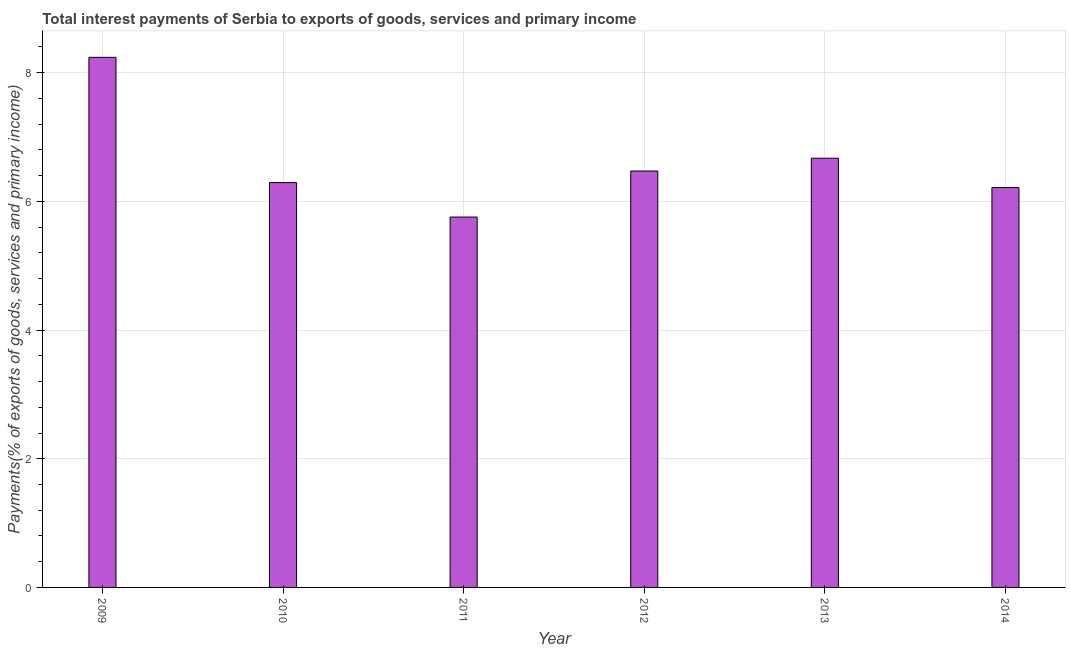Does the graph contain any zero values?
Keep it short and to the point. No. Does the graph contain grids?
Offer a terse response. Yes. What is the title of the graph?
Make the answer very short. Total interest payments of Serbia to exports of goods, services and primary income. What is the label or title of the X-axis?
Provide a succinct answer. Year. What is the label or title of the Y-axis?
Keep it short and to the point. Payments(% of exports of goods, services and primary income). What is the total interest payments on external debt in 2014?
Your answer should be compact. 6.21. Across all years, what is the maximum total interest payments on external debt?
Offer a very short reply. 8.24. Across all years, what is the minimum total interest payments on external debt?
Your answer should be very brief. 5.76. In which year was the total interest payments on external debt minimum?
Your response must be concise. 2011. What is the sum of the total interest payments on external debt?
Provide a short and direct response. 39.64. What is the difference between the total interest payments on external debt in 2011 and 2014?
Offer a very short reply. -0.46. What is the average total interest payments on external debt per year?
Offer a very short reply. 6.61. What is the median total interest payments on external debt?
Your answer should be compact. 6.38. In how many years, is the total interest payments on external debt greater than 2 %?
Ensure brevity in your answer.  6. What is the ratio of the total interest payments on external debt in 2009 to that in 2013?
Your response must be concise. 1.24. Is the total interest payments on external debt in 2009 less than that in 2012?
Offer a terse response. No. What is the difference between the highest and the second highest total interest payments on external debt?
Give a very brief answer. 1.57. What is the difference between the highest and the lowest total interest payments on external debt?
Offer a terse response. 2.48. In how many years, is the total interest payments on external debt greater than the average total interest payments on external debt taken over all years?
Give a very brief answer. 2. Are all the bars in the graph horizontal?
Provide a succinct answer. No. How many years are there in the graph?
Your answer should be compact. 6. What is the difference between two consecutive major ticks on the Y-axis?
Offer a terse response. 2. What is the Payments(% of exports of goods, services and primary income) in 2009?
Keep it short and to the point. 8.24. What is the Payments(% of exports of goods, services and primary income) in 2010?
Your answer should be very brief. 6.29. What is the Payments(% of exports of goods, services and primary income) of 2011?
Provide a succinct answer. 5.76. What is the Payments(% of exports of goods, services and primary income) of 2012?
Provide a succinct answer. 6.47. What is the Payments(% of exports of goods, services and primary income) of 2013?
Your response must be concise. 6.67. What is the Payments(% of exports of goods, services and primary income) of 2014?
Ensure brevity in your answer.  6.21. What is the difference between the Payments(% of exports of goods, services and primary income) in 2009 and 2010?
Your answer should be very brief. 1.95. What is the difference between the Payments(% of exports of goods, services and primary income) in 2009 and 2011?
Keep it short and to the point. 2.48. What is the difference between the Payments(% of exports of goods, services and primary income) in 2009 and 2012?
Make the answer very short. 1.77. What is the difference between the Payments(% of exports of goods, services and primary income) in 2009 and 2013?
Your answer should be compact. 1.57. What is the difference between the Payments(% of exports of goods, services and primary income) in 2009 and 2014?
Make the answer very short. 2.02. What is the difference between the Payments(% of exports of goods, services and primary income) in 2010 and 2011?
Offer a terse response. 0.54. What is the difference between the Payments(% of exports of goods, services and primary income) in 2010 and 2012?
Your response must be concise. -0.18. What is the difference between the Payments(% of exports of goods, services and primary income) in 2010 and 2013?
Offer a terse response. -0.38. What is the difference between the Payments(% of exports of goods, services and primary income) in 2010 and 2014?
Ensure brevity in your answer.  0.08. What is the difference between the Payments(% of exports of goods, services and primary income) in 2011 and 2012?
Your response must be concise. -0.72. What is the difference between the Payments(% of exports of goods, services and primary income) in 2011 and 2013?
Provide a succinct answer. -0.91. What is the difference between the Payments(% of exports of goods, services and primary income) in 2011 and 2014?
Offer a terse response. -0.46. What is the difference between the Payments(% of exports of goods, services and primary income) in 2012 and 2013?
Provide a succinct answer. -0.2. What is the difference between the Payments(% of exports of goods, services and primary income) in 2012 and 2014?
Offer a very short reply. 0.26. What is the difference between the Payments(% of exports of goods, services and primary income) in 2013 and 2014?
Offer a very short reply. 0.46. What is the ratio of the Payments(% of exports of goods, services and primary income) in 2009 to that in 2010?
Your answer should be very brief. 1.31. What is the ratio of the Payments(% of exports of goods, services and primary income) in 2009 to that in 2011?
Offer a very short reply. 1.43. What is the ratio of the Payments(% of exports of goods, services and primary income) in 2009 to that in 2012?
Offer a terse response. 1.27. What is the ratio of the Payments(% of exports of goods, services and primary income) in 2009 to that in 2013?
Make the answer very short. 1.24. What is the ratio of the Payments(% of exports of goods, services and primary income) in 2009 to that in 2014?
Offer a terse response. 1.33. What is the ratio of the Payments(% of exports of goods, services and primary income) in 2010 to that in 2011?
Give a very brief answer. 1.09. What is the ratio of the Payments(% of exports of goods, services and primary income) in 2010 to that in 2012?
Ensure brevity in your answer.  0.97. What is the ratio of the Payments(% of exports of goods, services and primary income) in 2010 to that in 2013?
Your answer should be very brief. 0.94. What is the ratio of the Payments(% of exports of goods, services and primary income) in 2010 to that in 2014?
Make the answer very short. 1.01. What is the ratio of the Payments(% of exports of goods, services and primary income) in 2011 to that in 2012?
Keep it short and to the point. 0.89. What is the ratio of the Payments(% of exports of goods, services and primary income) in 2011 to that in 2013?
Give a very brief answer. 0.86. What is the ratio of the Payments(% of exports of goods, services and primary income) in 2011 to that in 2014?
Offer a terse response. 0.93. What is the ratio of the Payments(% of exports of goods, services and primary income) in 2012 to that in 2014?
Give a very brief answer. 1.04. What is the ratio of the Payments(% of exports of goods, services and primary income) in 2013 to that in 2014?
Give a very brief answer. 1.07. 